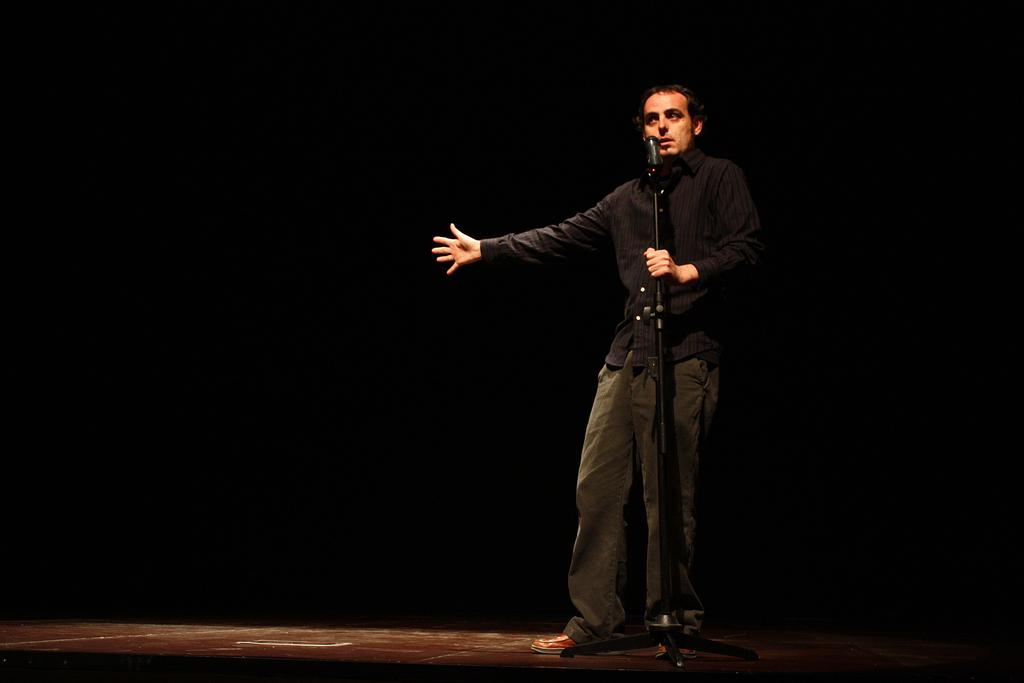What is the main subject of subject of the image? There is a person in the image. What is the person wearing? The person is wearing a black dress. What is the person doing in the image? The person is standing and holding a microphone. What is the color of the background in the image? The background of the image is black. What type of music can be heard playing in the background of the image? There is no music playing in the background of the image; it is a still photograph. Can you see a cherry on the person's head in the image? No, there is no cherry present on the person's head in the image. 